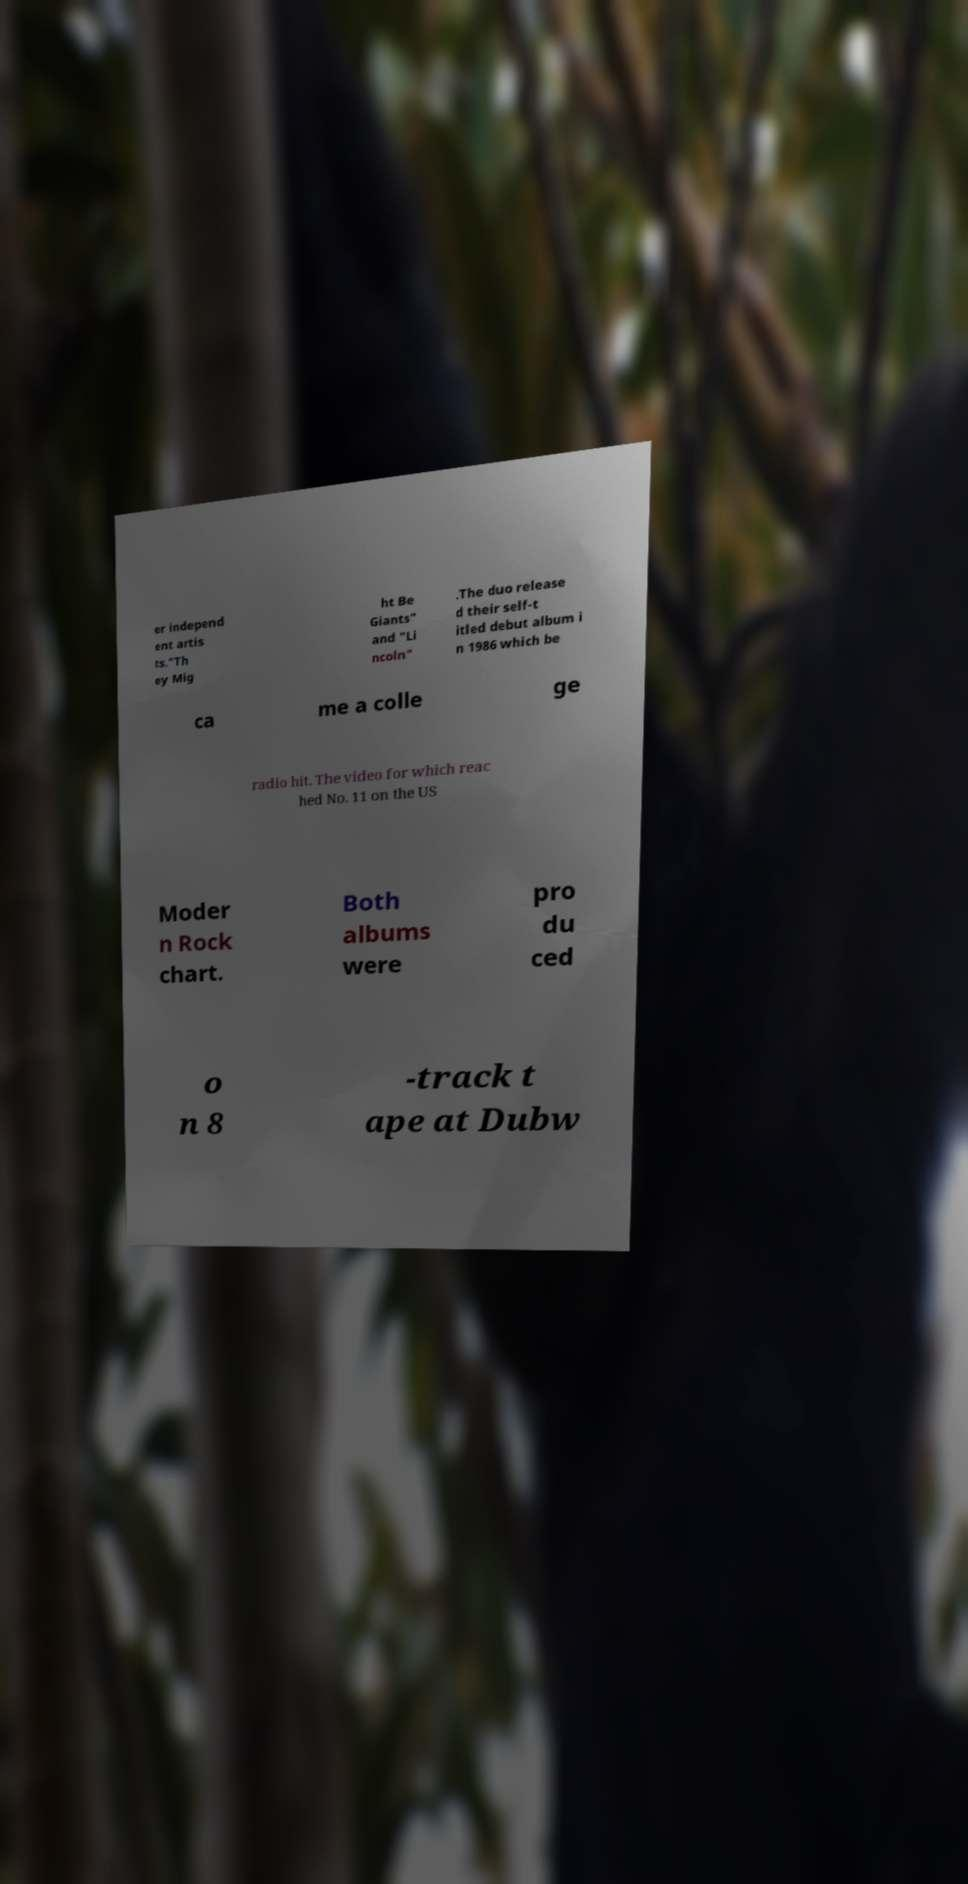Can you accurately transcribe the text from the provided image for me? er independ ent artis ts."Th ey Mig ht Be Giants" and "Li ncoln" .The duo release d their self-t itled debut album i n 1986 which be ca me a colle ge radio hit. The video for which reac hed No. 11 on the US Moder n Rock chart. Both albums were pro du ced o n 8 -track t ape at Dubw 